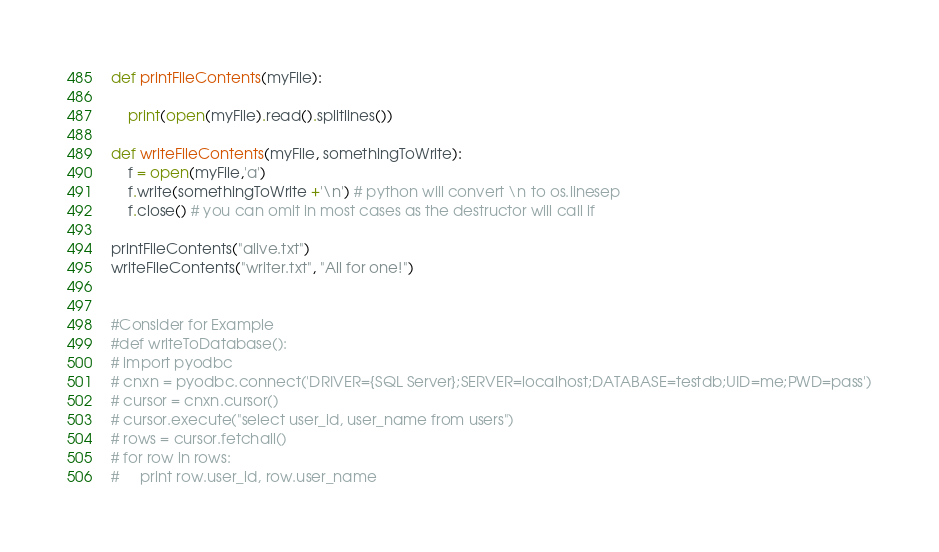Convert code to text. <code><loc_0><loc_0><loc_500><loc_500><_Python_>def printFileContents(myFile):
	
	print(open(myFile).read().splitlines())
	
def writeFileContents(myFile, somethingToWrite):
	f = open(myFile,'a')
	f.write(somethingToWrite +'\n') # python will convert \n to os.linesep
	f.close() # you can omit in most cases as the destructor will call if

printFileContents("alive.txt")
writeFileContents("writer.txt", "All for one!")


#Consider for Example
#def writeToDatabase():
# import pyodbc
# cnxn = pyodbc.connect('DRIVER={SQL Server};SERVER=localhost;DATABASE=testdb;UID=me;PWD=pass')
# cursor = cnxn.cursor()
# cursor.execute("select user_id, user_name from users")
# rows = cursor.fetchall()
# for row in rows:
#     print row.user_id, row.user_name</code> 